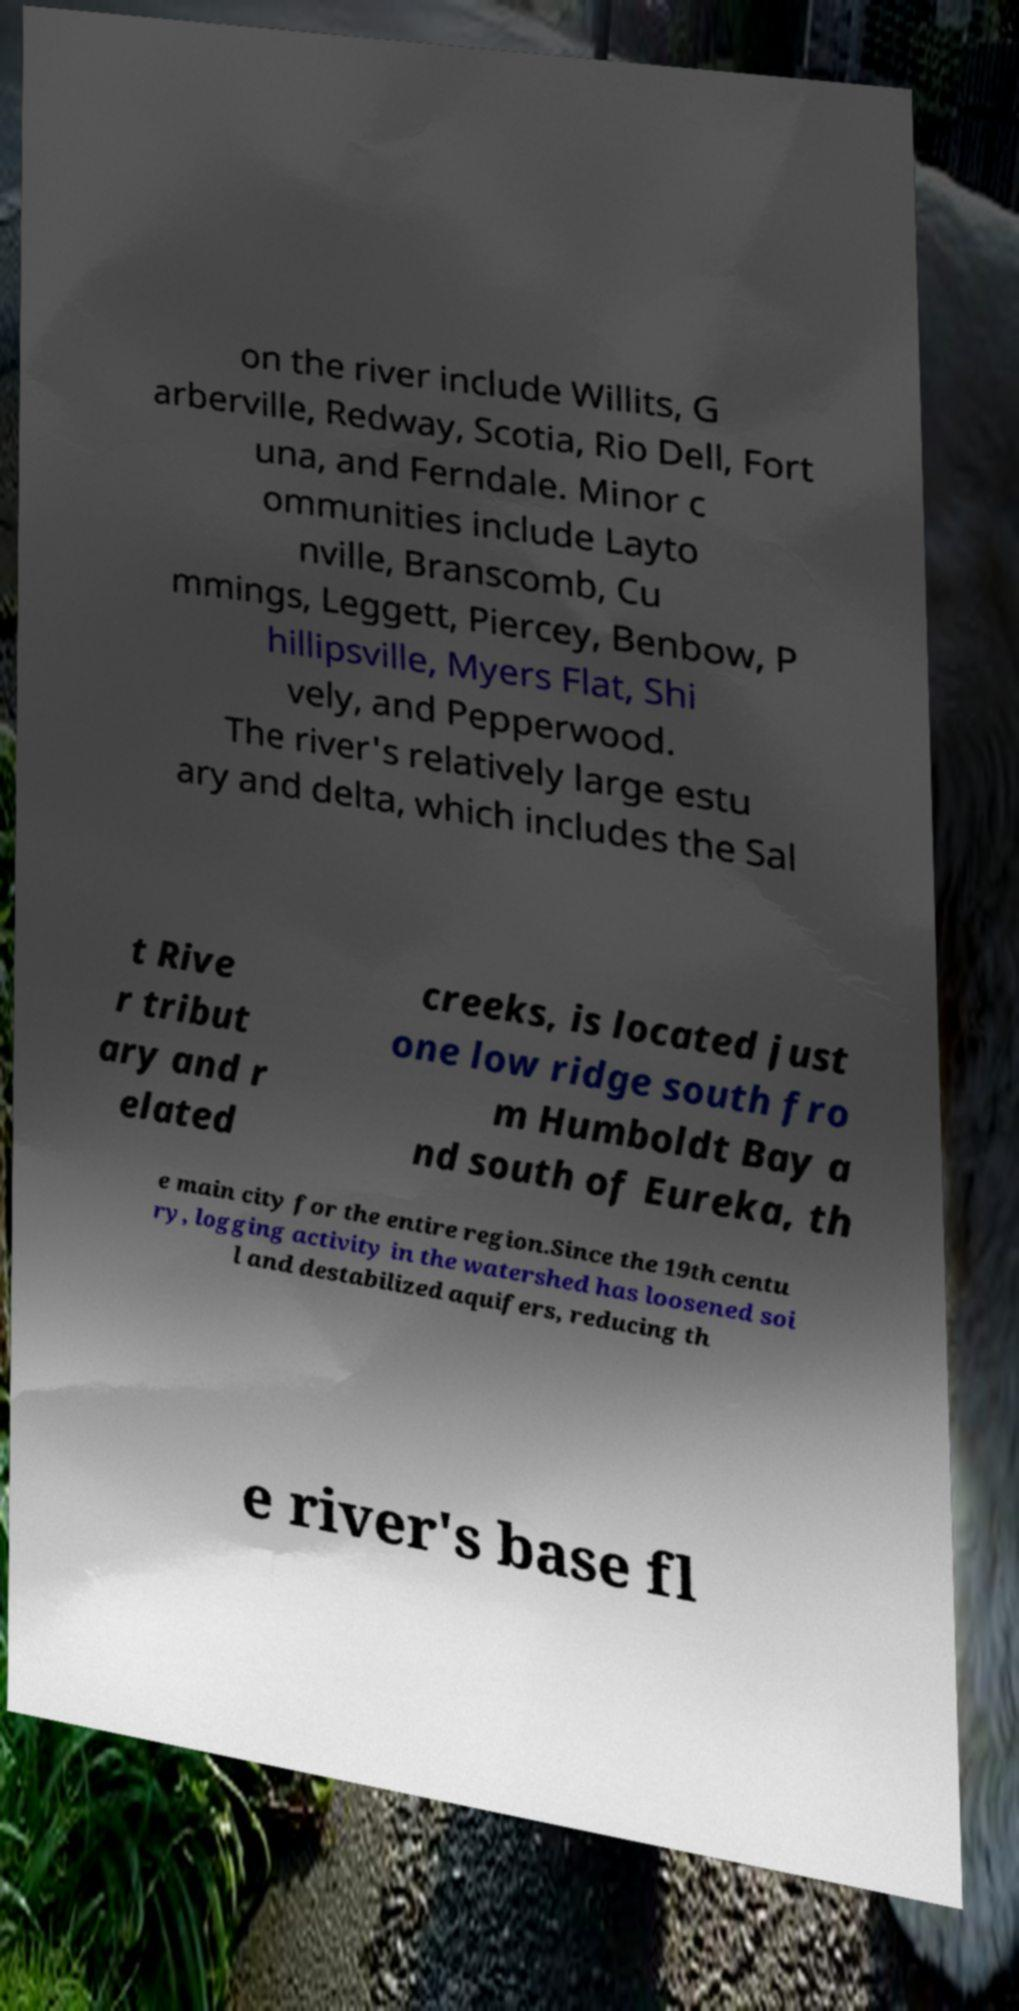There's text embedded in this image that I need extracted. Can you transcribe it verbatim? on the river include Willits, G arberville, Redway, Scotia, Rio Dell, Fort una, and Ferndale. Minor c ommunities include Layto nville, Branscomb, Cu mmings, Leggett, Piercey, Benbow, P hillipsville, Myers Flat, Shi vely, and Pepperwood. The river's relatively large estu ary and delta, which includes the Sal t Rive r tribut ary and r elated creeks, is located just one low ridge south fro m Humboldt Bay a nd south of Eureka, th e main city for the entire region.Since the 19th centu ry, logging activity in the watershed has loosened soi l and destabilized aquifers, reducing th e river's base fl 